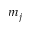Convert formula to latex. <formula><loc_0><loc_0><loc_500><loc_500>m _ { j }</formula> 